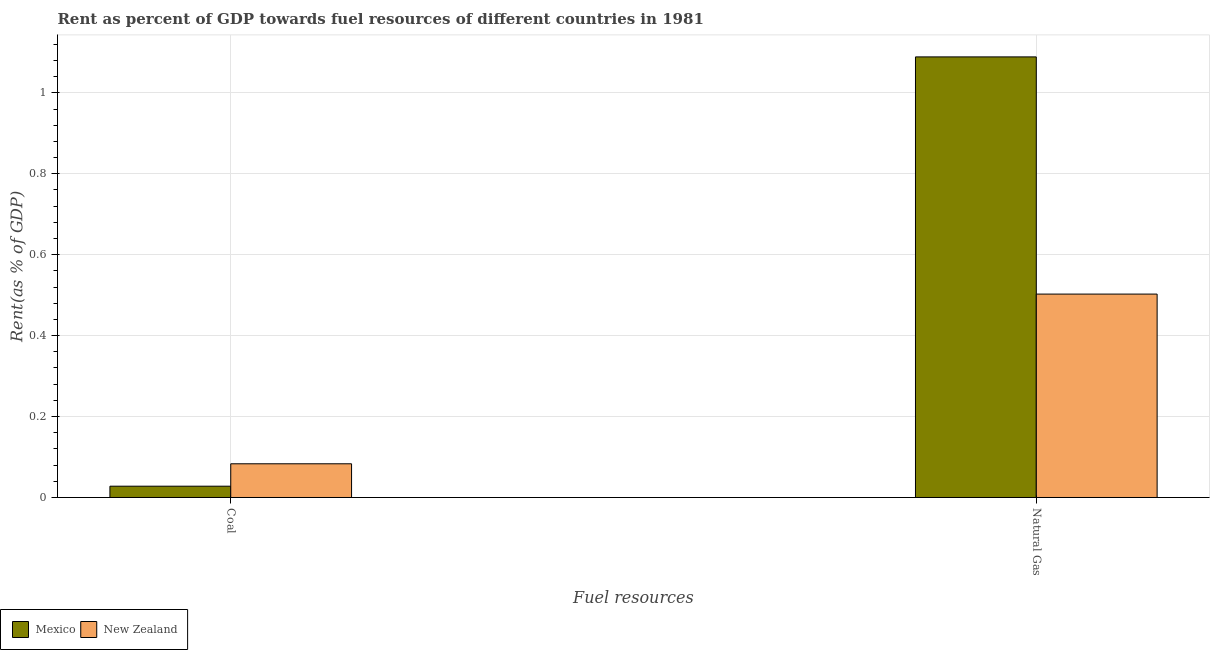How many groups of bars are there?
Your response must be concise. 2. Are the number of bars per tick equal to the number of legend labels?
Keep it short and to the point. Yes. How many bars are there on the 1st tick from the left?
Ensure brevity in your answer.  2. What is the label of the 1st group of bars from the left?
Make the answer very short. Coal. What is the rent towards coal in New Zealand?
Give a very brief answer. 0.08. Across all countries, what is the maximum rent towards coal?
Offer a terse response. 0.08. Across all countries, what is the minimum rent towards natural gas?
Give a very brief answer. 0.5. In which country was the rent towards coal maximum?
Offer a very short reply. New Zealand. What is the total rent towards coal in the graph?
Provide a succinct answer. 0.11. What is the difference between the rent towards natural gas in Mexico and that in New Zealand?
Offer a very short reply. 0.59. What is the difference between the rent towards coal in Mexico and the rent towards natural gas in New Zealand?
Keep it short and to the point. -0.47. What is the average rent towards natural gas per country?
Your answer should be compact. 0.8. What is the difference between the rent towards coal and rent towards natural gas in New Zealand?
Provide a succinct answer. -0.42. In how many countries, is the rent towards coal greater than 0.4 %?
Ensure brevity in your answer.  0. What is the ratio of the rent towards natural gas in Mexico to that in New Zealand?
Your response must be concise. 2.17. Are all the bars in the graph horizontal?
Provide a succinct answer. No. How many countries are there in the graph?
Provide a short and direct response. 2. Are the values on the major ticks of Y-axis written in scientific E-notation?
Give a very brief answer. No. Does the graph contain any zero values?
Your answer should be very brief. No. How are the legend labels stacked?
Ensure brevity in your answer.  Horizontal. What is the title of the graph?
Make the answer very short. Rent as percent of GDP towards fuel resources of different countries in 1981. Does "Finland" appear as one of the legend labels in the graph?
Your response must be concise. No. What is the label or title of the X-axis?
Your response must be concise. Fuel resources. What is the label or title of the Y-axis?
Give a very brief answer. Rent(as % of GDP). What is the Rent(as % of GDP) in Mexico in Coal?
Offer a terse response. 0.03. What is the Rent(as % of GDP) of New Zealand in Coal?
Your response must be concise. 0.08. What is the Rent(as % of GDP) of Mexico in Natural Gas?
Your answer should be compact. 1.09. What is the Rent(as % of GDP) in New Zealand in Natural Gas?
Your response must be concise. 0.5. Across all Fuel resources, what is the maximum Rent(as % of GDP) in Mexico?
Provide a short and direct response. 1.09. Across all Fuel resources, what is the maximum Rent(as % of GDP) of New Zealand?
Your answer should be compact. 0.5. Across all Fuel resources, what is the minimum Rent(as % of GDP) in Mexico?
Give a very brief answer. 0.03. Across all Fuel resources, what is the minimum Rent(as % of GDP) of New Zealand?
Offer a terse response. 0.08. What is the total Rent(as % of GDP) of Mexico in the graph?
Offer a terse response. 1.12. What is the total Rent(as % of GDP) in New Zealand in the graph?
Offer a terse response. 0.59. What is the difference between the Rent(as % of GDP) of Mexico in Coal and that in Natural Gas?
Provide a succinct answer. -1.06. What is the difference between the Rent(as % of GDP) in New Zealand in Coal and that in Natural Gas?
Keep it short and to the point. -0.42. What is the difference between the Rent(as % of GDP) in Mexico in Coal and the Rent(as % of GDP) in New Zealand in Natural Gas?
Provide a short and direct response. -0.47. What is the average Rent(as % of GDP) of Mexico per Fuel resources?
Offer a terse response. 0.56. What is the average Rent(as % of GDP) of New Zealand per Fuel resources?
Offer a terse response. 0.29. What is the difference between the Rent(as % of GDP) in Mexico and Rent(as % of GDP) in New Zealand in Coal?
Give a very brief answer. -0.06. What is the difference between the Rent(as % of GDP) in Mexico and Rent(as % of GDP) in New Zealand in Natural Gas?
Make the answer very short. 0.59. What is the ratio of the Rent(as % of GDP) of Mexico in Coal to that in Natural Gas?
Make the answer very short. 0.03. What is the ratio of the Rent(as % of GDP) in New Zealand in Coal to that in Natural Gas?
Your response must be concise. 0.17. What is the difference between the highest and the second highest Rent(as % of GDP) in Mexico?
Your response must be concise. 1.06. What is the difference between the highest and the second highest Rent(as % of GDP) of New Zealand?
Make the answer very short. 0.42. What is the difference between the highest and the lowest Rent(as % of GDP) in Mexico?
Give a very brief answer. 1.06. What is the difference between the highest and the lowest Rent(as % of GDP) of New Zealand?
Provide a succinct answer. 0.42. 